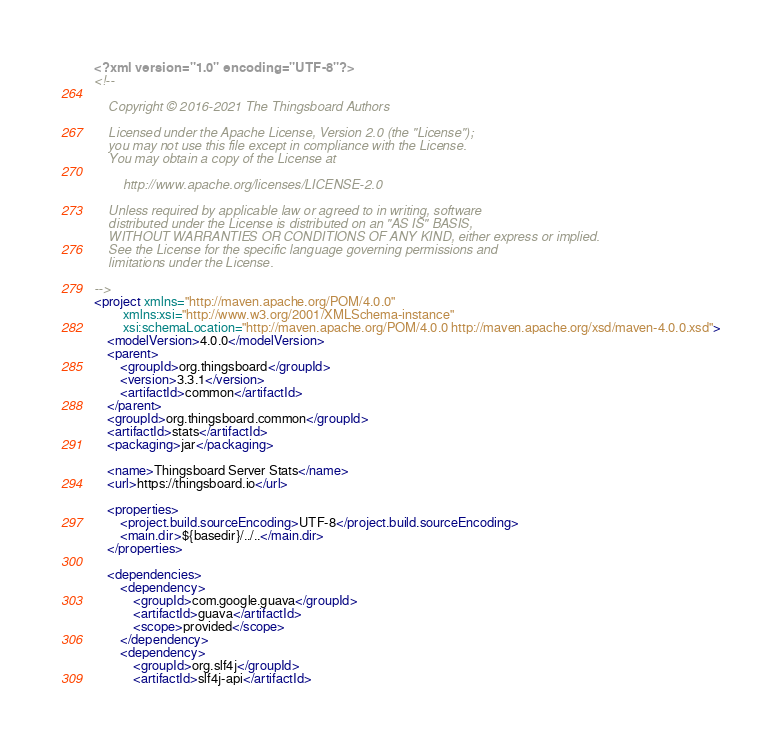Convert code to text. <code><loc_0><loc_0><loc_500><loc_500><_XML_><?xml version="1.0" encoding="UTF-8"?>
<!--

    Copyright © 2016-2021 The Thingsboard Authors

    Licensed under the Apache License, Version 2.0 (the "License");
    you may not use this file except in compliance with the License.
    You may obtain a copy of the License at

        http://www.apache.org/licenses/LICENSE-2.0

    Unless required by applicable law or agreed to in writing, software
    distributed under the License is distributed on an "AS IS" BASIS,
    WITHOUT WARRANTIES OR CONDITIONS OF ANY KIND, either express or implied.
    See the License for the specific language governing permissions and
    limitations under the License.

-->
<project xmlns="http://maven.apache.org/POM/4.0.0"
         xmlns:xsi="http://www.w3.org/2001/XMLSchema-instance"
         xsi:schemaLocation="http://maven.apache.org/POM/4.0.0 http://maven.apache.org/xsd/maven-4.0.0.xsd">
    <modelVersion>4.0.0</modelVersion>
    <parent>
        <groupId>org.thingsboard</groupId>
        <version>3.3.1</version>
        <artifactId>common</artifactId>
    </parent>
    <groupId>org.thingsboard.common</groupId>
    <artifactId>stats</artifactId>
    <packaging>jar</packaging>

    <name>Thingsboard Server Stats</name>
    <url>https://thingsboard.io</url>

    <properties>
        <project.build.sourceEncoding>UTF-8</project.build.sourceEncoding>
        <main.dir>${basedir}/../..</main.dir>
    </properties>

    <dependencies>
        <dependency>
            <groupId>com.google.guava</groupId>
            <artifactId>guava</artifactId>
            <scope>provided</scope>
        </dependency>
        <dependency>
            <groupId>org.slf4j</groupId>
            <artifactId>slf4j-api</artifactId></code> 